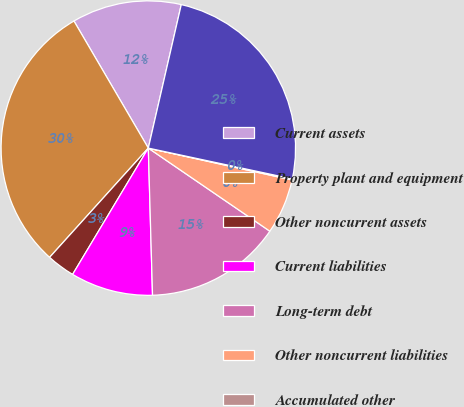Convert chart. <chart><loc_0><loc_0><loc_500><loc_500><pie_chart><fcel>Current assets<fcel>Property plant and equipment<fcel>Other noncurrent assets<fcel>Current liabilities<fcel>Long-term debt<fcel>Other noncurrent liabilities<fcel>Accumulated other<fcel>Owners' equity<nl><fcel>12.02%<fcel>29.88%<fcel>3.1%<fcel>9.05%<fcel>15.0%<fcel>6.07%<fcel>0.12%<fcel>24.76%<nl></chart> 